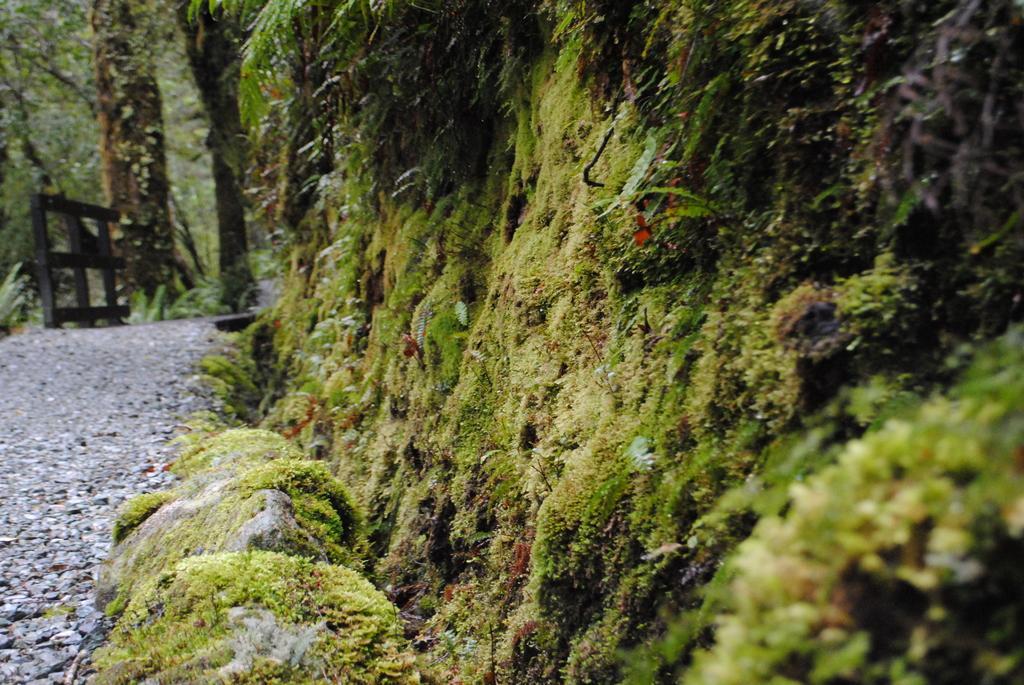Could you give a brief overview of what you see in this image? In this picture we can see the moss and rocks. On the left side of the rocks there is a path and an object. Behind the object there are trees. 